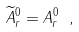<formula> <loc_0><loc_0><loc_500><loc_500>\widetilde { A } ^ { 0 } _ { r } = A ^ { 0 } _ { r } \ ,</formula> 